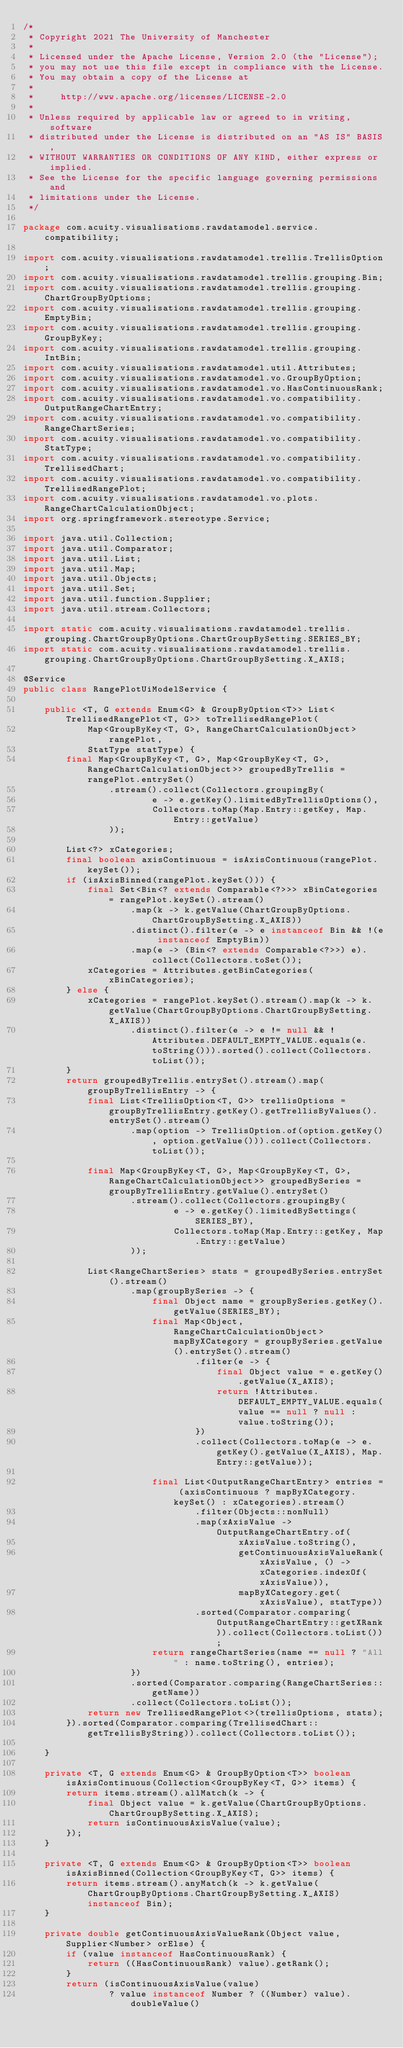Convert code to text. <code><loc_0><loc_0><loc_500><loc_500><_Java_>/*
 * Copyright 2021 The University of Manchester
 *
 * Licensed under the Apache License, Version 2.0 (the "License");
 * you may not use this file except in compliance with the License.
 * You may obtain a copy of the License at
 *
 *     http://www.apache.org/licenses/LICENSE-2.0
 *
 * Unless required by applicable law or agreed to in writing, software
 * distributed under the License is distributed on an "AS IS" BASIS,
 * WITHOUT WARRANTIES OR CONDITIONS OF ANY KIND, either express or implied.
 * See the License for the specific language governing permissions and
 * limitations under the License.
 */

package com.acuity.visualisations.rawdatamodel.service.compatibility;

import com.acuity.visualisations.rawdatamodel.trellis.TrellisOption;
import com.acuity.visualisations.rawdatamodel.trellis.grouping.Bin;
import com.acuity.visualisations.rawdatamodel.trellis.grouping.ChartGroupByOptions;
import com.acuity.visualisations.rawdatamodel.trellis.grouping.EmptyBin;
import com.acuity.visualisations.rawdatamodel.trellis.grouping.GroupByKey;
import com.acuity.visualisations.rawdatamodel.trellis.grouping.IntBin;
import com.acuity.visualisations.rawdatamodel.util.Attributes;
import com.acuity.visualisations.rawdatamodel.vo.GroupByOption;
import com.acuity.visualisations.rawdatamodel.vo.HasContinuousRank;
import com.acuity.visualisations.rawdatamodel.vo.compatibility.OutputRangeChartEntry;
import com.acuity.visualisations.rawdatamodel.vo.compatibility.RangeChartSeries;
import com.acuity.visualisations.rawdatamodel.vo.compatibility.StatType;
import com.acuity.visualisations.rawdatamodel.vo.compatibility.TrellisedChart;
import com.acuity.visualisations.rawdatamodel.vo.compatibility.TrellisedRangePlot;
import com.acuity.visualisations.rawdatamodel.vo.plots.RangeChartCalculationObject;
import org.springframework.stereotype.Service;

import java.util.Collection;
import java.util.Comparator;
import java.util.List;
import java.util.Map;
import java.util.Objects;
import java.util.Set;
import java.util.function.Supplier;
import java.util.stream.Collectors;

import static com.acuity.visualisations.rawdatamodel.trellis.grouping.ChartGroupByOptions.ChartGroupBySetting.SERIES_BY;
import static com.acuity.visualisations.rawdatamodel.trellis.grouping.ChartGroupByOptions.ChartGroupBySetting.X_AXIS;

@Service
public class RangePlotUiModelService {

    public <T, G extends Enum<G> & GroupByOption<T>> List<TrellisedRangePlot<T, G>> toTrellisedRangePlot(
            Map<GroupByKey<T, G>, RangeChartCalculationObject> rangePlot,
            StatType statType) {
        final Map<GroupByKey<T, G>, Map<GroupByKey<T, G>, RangeChartCalculationObject>> groupedByTrellis = rangePlot.entrySet()
                .stream().collect(Collectors.groupingBy(
                        e -> e.getKey().limitedByTrellisOptions(),
                        Collectors.toMap(Map.Entry::getKey, Map.Entry::getValue)
                ));

        List<?> xCategories;
        final boolean axisContinuous = isAxisContinuous(rangePlot.keySet());
        if (isAxisBinned(rangePlot.keySet())) {
            final Set<Bin<? extends Comparable<?>>> xBinCategories = rangePlot.keySet().stream()
                    .map(k -> k.getValue(ChartGroupByOptions.ChartGroupBySetting.X_AXIS))
                    .distinct().filter(e -> e instanceof Bin && !(e instanceof EmptyBin))
                    .map(e -> (Bin<? extends Comparable<?>>) e).collect(Collectors.toSet());
            xCategories = Attributes.getBinCategories(xBinCategories);
        } else {
            xCategories = rangePlot.keySet().stream().map(k -> k.getValue(ChartGroupByOptions.ChartGroupBySetting.X_AXIS))
                    .distinct().filter(e -> e != null && !Attributes.DEFAULT_EMPTY_VALUE.equals(e.toString())).sorted().collect(Collectors.toList());
        }
        return groupedByTrellis.entrySet().stream().map(groupByTrellisEntry -> {
            final List<TrellisOption<T, G>> trellisOptions = groupByTrellisEntry.getKey().getTrellisByValues().entrySet().stream()
                    .map(option -> TrellisOption.of(option.getKey(), option.getValue())).collect(Collectors.toList());

            final Map<GroupByKey<T, G>, Map<GroupByKey<T, G>, RangeChartCalculationObject>> groupedBySeries = groupByTrellisEntry.getValue().entrySet()
                    .stream().collect(Collectors.groupingBy(
                            e -> e.getKey().limitedBySettings(SERIES_BY),
                            Collectors.toMap(Map.Entry::getKey, Map.Entry::getValue)
                    ));

            List<RangeChartSeries> stats = groupedBySeries.entrySet().stream()
                    .map(groupBySeries -> {
                        final Object name = groupBySeries.getKey().getValue(SERIES_BY);
                        final Map<Object, RangeChartCalculationObject> mapByXCategory = groupBySeries.getValue().entrySet().stream()
                                .filter(e -> {
                                    final Object value = e.getKey().getValue(X_AXIS);
                                    return !Attributes.DEFAULT_EMPTY_VALUE.equals(value == null ? null : value.toString());
                                })
                                .collect(Collectors.toMap(e -> e.getKey().getValue(X_AXIS), Map.Entry::getValue));

                        final List<OutputRangeChartEntry> entries = (axisContinuous ? mapByXCategory.keySet() : xCategories).stream()
                                .filter(Objects::nonNull)
                                .map(xAxisValue -> OutputRangeChartEntry.of(
                                        xAxisValue.toString(),
                                        getContinuousAxisValueRank(xAxisValue, () -> xCategories.indexOf(xAxisValue)),
                                        mapByXCategory.get(xAxisValue), statType))
                                .sorted(Comparator.comparing(OutputRangeChartEntry::getXRank)).collect(Collectors.toList());
                        return rangeChartSeries(name == null ? "All" : name.toString(), entries);
                    })
                    .sorted(Comparator.comparing(RangeChartSeries::getName))
                    .collect(Collectors.toList());
            return new TrellisedRangePlot<>(trellisOptions, stats);
        }).sorted(Comparator.comparing(TrellisedChart::getTrellisByString)).collect(Collectors.toList());

    }

    private <T, G extends Enum<G> & GroupByOption<T>> boolean isAxisContinuous(Collection<GroupByKey<T, G>> items) {
        return items.stream().allMatch(k -> {
            final Object value = k.getValue(ChartGroupByOptions.ChartGroupBySetting.X_AXIS);
            return isContinuousAxisValue(value);
        });
    }

    private <T, G extends Enum<G> & GroupByOption<T>> boolean isAxisBinned(Collection<GroupByKey<T, G>> items) {
        return items.stream().anyMatch(k -> k.getValue(ChartGroupByOptions.ChartGroupBySetting.X_AXIS) instanceof Bin);
    }

    private double getContinuousAxisValueRank(Object value, Supplier<Number> orElse) {
        if (value instanceof HasContinuousRank) {
            return ((HasContinuousRank) value).getRank();
        }
        return (isContinuousAxisValue(value)
                ? value instanceof Number ? ((Number) value).doubleValue()</code> 